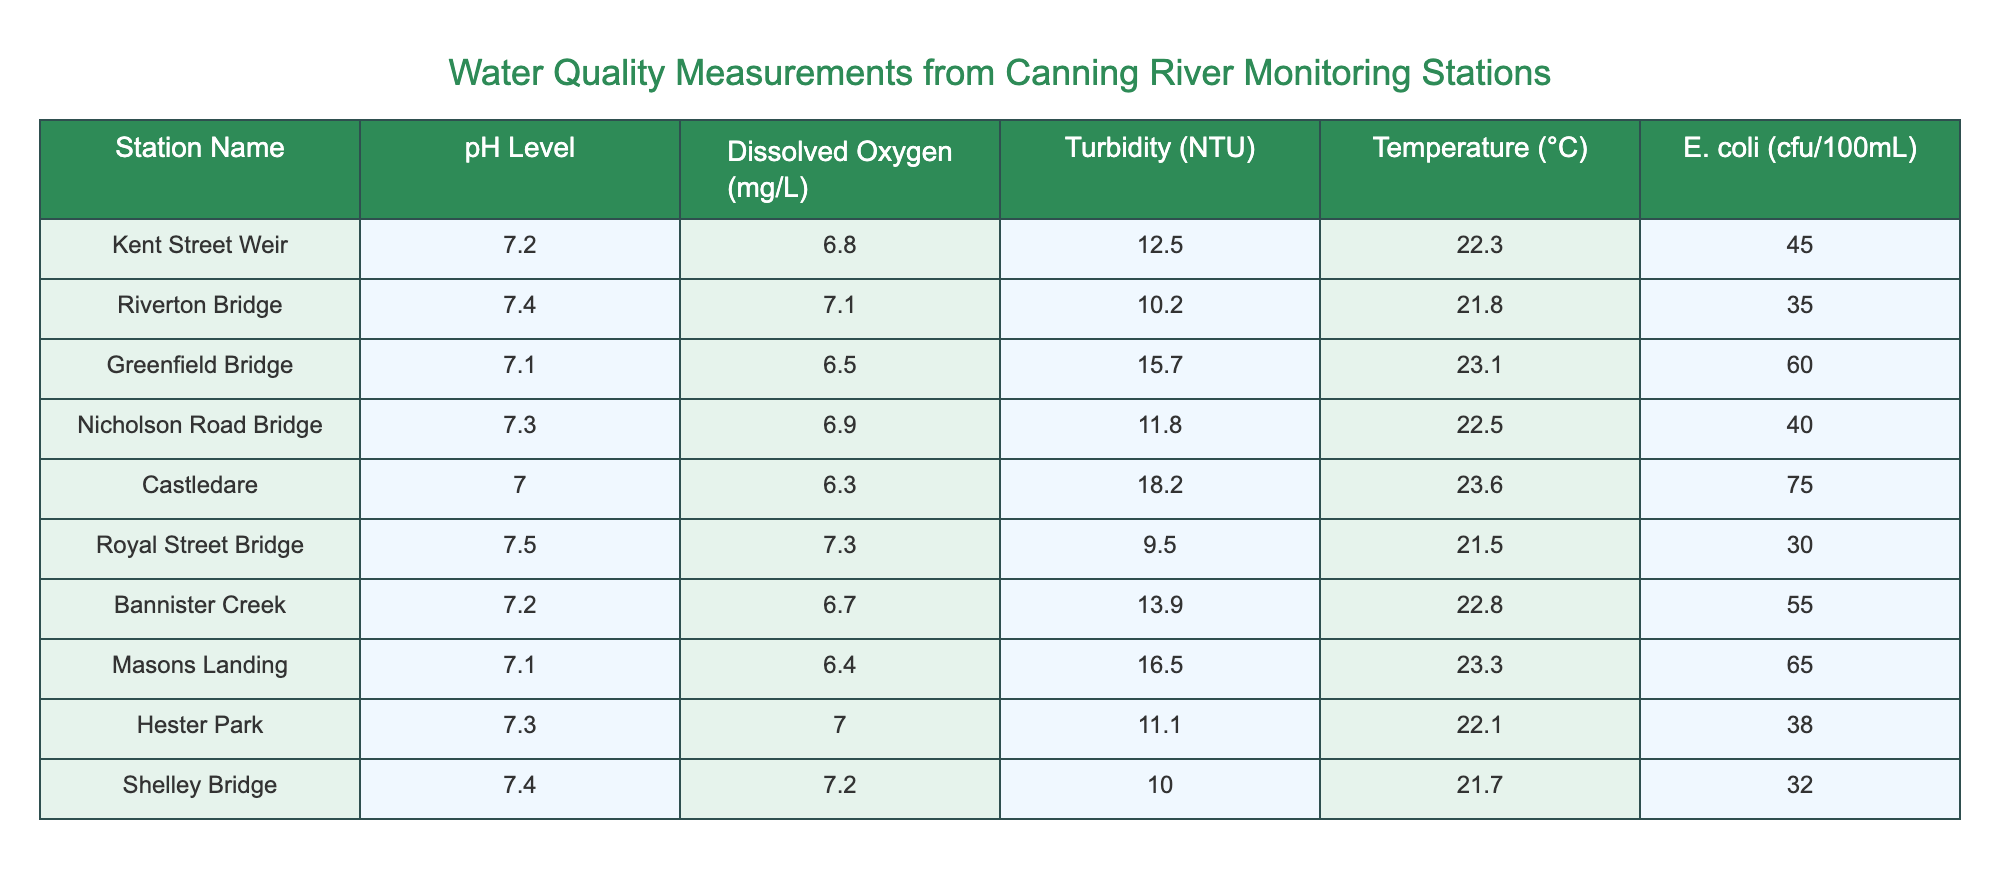What is the pH level at Riverton Bridge? The table shows a row for Riverton Bridge, and under the column for pH Level, the value is listed as 7.4.
Answer: 7.4 Which monitoring station reports the highest E. coli count? By examining the E. coli column, Castledare has the highest value recorded at 75 cfu/100mL, compared to other stations.
Answer: Castledare What is the average temperature across all monitoring stations? To find the average temperature, sum all the temperature values: (22.3 + 21.8 + 23.1 + 22.5 + 23.6 + 21.5 + 22.8 + 23.3 + 22.1 + 21.7) = 223.4. There are 10 stations, so the average is 223.4 / 10 = 22.34.
Answer: 22.34 Is the dissolved oxygen level at Greenfield Bridge greater than 6.5 mg/L? The table shows that the dissolved oxygen level at Greenfield Bridge is 6.5 mg/L, which means it is not greater.
Answer: No How does the turbidity at Masons Landing compare to that at Kent Street Weir? At Masons Landing, the turbidity is 16.5 NTU while at Kent Street Weir it is 12.5 NTU. Therefore, Masons Landing has higher turbidity by a difference of 16.5 - 12.5 = 4 NTU.
Answer: Higher by 4 NTU What is the total dissolved oxygen (in mg/L) for all monitoring stations? Sum the dissolved oxygen values from all stations: (6.8 + 7.1 + 6.5 + 6.9 + 6.3 + 7.3 + 6.7 + 6.4 + 7.0 + 7.2) = 69.8 mg/L in total.
Answer: 69.8 mg/L Which station has the lowest pH level, and what is that value? Checking the pH levels, Castledare has the lowest pH at 7.0.
Answer: 7.0 Is there any relation between temperature and E. coli count based on the provided data? To assess the relationship, we can observe that while temperature ranges from 21.5 to 23.6 °C, E. coli counts vary from 30 to 75. However, there is no clear pattern, as temperature does not consistently rise or fall with E. coli counts across the stations.
Answer: No clear pattern How many stations have a dissolved oxygen level above 7 mg/L? Checking the dissolved oxygen values, Riverton Bridge (7.1), Royal Street Bridge (7.3), and Shelley Bridge (7.2) all exceed 7 mg/L. Therefore, there are 3 stations with levels above this threshold.
Answer: 3 stations 